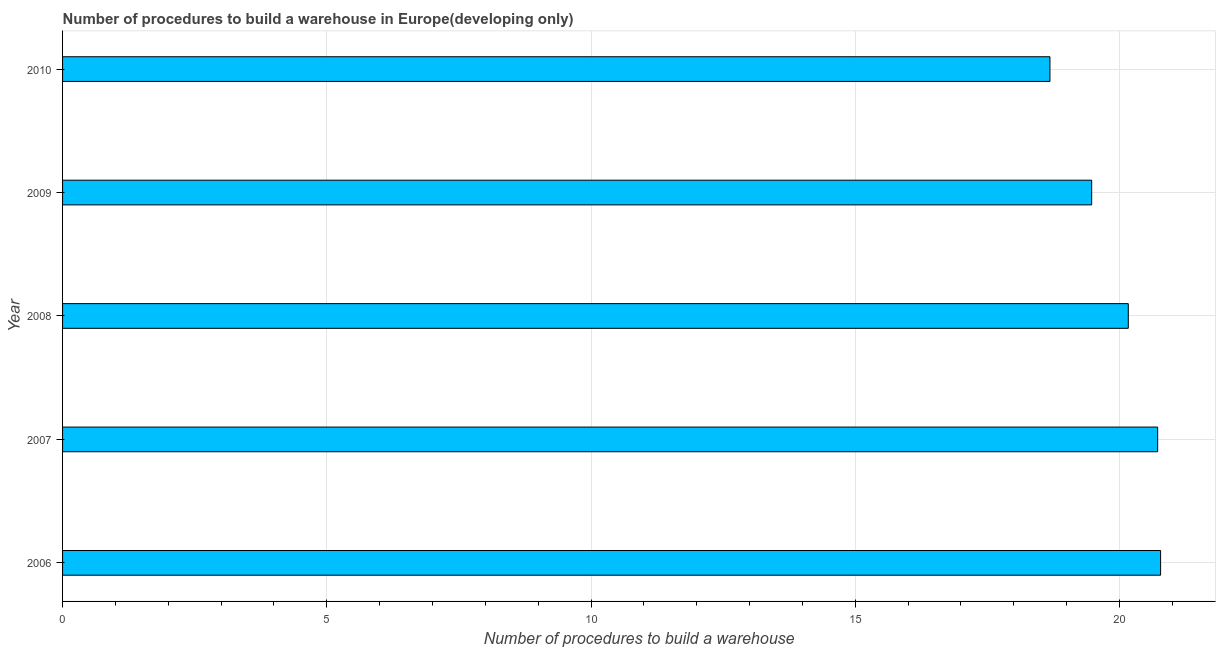What is the title of the graph?
Your answer should be compact. Number of procedures to build a warehouse in Europe(developing only). What is the label or title of the X-axis?
Make the answer very short. Number of procedures to build a warehouse. What is the number of procedures to build a warehouse in 2009?
Provide a succinct answer. 19.47. Across all years, what is the maximum number of procedures to build a warehouse?
Keep it short and to the point. 20.78. Across all years, what is the minimum number of procedures to build a warehouse?
Give a very brief answer. 18.68. In which year was the number of procedures to build a warehouse minimum?
Provide a succinct answer. 2010. What is the sum of the number of procedures to build a warehouse?
Your response must be concise. 99.82. What is the difference between the number of procedures to build a warehouse in 2006 and 2007?
Give a very brief answer. 0.06. What is the average number of procedures to build a warehouse per year?
Keep it short and to the point. 19.96. What is the median number of procedures to build a warehouse?
Make the answer very short. 20.17. In how many years, is the number of procedures to build a warehouse greater than 10 ?
Ensure brevity in your answer.  5. Do a majority of the years between 2006 and 2010 (inclusive) have number of procedures to build a warehouse greater than 8 ?
Your response must be concise. Yes. What is the ratio of the number of procedures to build a warehouse in 2009 to that in 2010?
Ensure brevity in your answer.  1.04. Is the number of procedures to build a warehouse in 2007 less than that in 2009?
Give a very brief answer. No. What is the difference between the highest and the second highest number of procedures to build a warehouse?
Your response must be concise. 0.06. Is the sum of the number of procedures to build a warehouse in 2007 and 2008 greater than the maximum number of procedures to build a warehouse across all years?
Make the answer very short. Yes. What is the difference between the highest and the lowest number of procedures to build a warehouse?
Make the answer very short. 2.09. In how many years, is the number of procedures to build a warehouse greater than the average number of procedures to build a warehouse taken over all years?
Your answer should be very brief. 3. How many bars are there?
Your answer should be very brief. 5. Are all the bars in the graph horizontal?
Provide a short and direct response. Yes. What is the difference between two consecutive major ticks on the X-axis?
Keep it short and to the point. 5. Are the values on the major ticks of X-axis written in scientific E-notation?
Offer a very short reply. No. What is the Number of procedures to build a warehouse in 2006?
Make the answer very short. 20.78. What is the Number of procedures to build a warehouse in 2007?
Keep it short and to the point. 20.72. What is the Number of procedures to build a warehouse of 2008?
Make the answer very short. 20.17. What is the Number of procedures to build a warehouse in 2009?
Provide a short and direct response. 19.47. What is the Number of procedures to build a warehouse of 2010?
Ensure brevity in your answer.  18.68. What is the difference between the Number of procedures to build a warehouse in 2006 and 2007?
Ensure brevity in your answer.  0.06. What is the difference between the Number of procedures to build a warehouse in 2006 and 2008?
Your response must be concise. 0.61. What is the difference between the Number of procedures to build a warehouse in 2006 and 2009?
Offer a terse response. 1.3. What is the difference between the Number of procedures to build a warehouse in 2006 and 2010?
Provide a short and direct response. 2.09. What is the difference between the Number of procedures to build a warehouse in 2007 and 2008?
Your answer should be compact. 0.56. What is the difference between the Number of procedures to build a warehouse in 2007 and 2009?
Ensure brevity in your answer.  1.25. What is the difference between the Number of procedures to build a warehouse in 2007 and 2010?
Your answer should be compact. 2.04. What is the difference between the Number of procedures to build a warehouse in 2008 and 2009?
Your answer should be compact. 0.69. What is the difference between the Number of procedures to build a warehouse in 2008 and 2010?
Keep it short and to the point. 1.48. What is the difference between the Number of procedures to build a warehouse in 2009 and 2010?
Make the answer very short. 0.79. What is the ratio of the Number of procedures to build a warehouse in 2006 to that in 2007?
Offer a terse response. 1. What is the ratio of the Number of procedures to build a warehouse in 2006 to that in 2008?
Give a very brief answer. 1.03. What is the ratio of the Number of procedures to build a warehouse in 2006 to that in 2009?
Give a very brief answer. 1.07. What is the ratio of the Number of procedures to build a warehouse in 2006 to that in 2010?
Ensure brevity in your answer.  1.11. What is the ratio of the Number of procedures to build a warehouse in 2007 to that in 2008?
Provide a succinct answer. 1.03. What is the ratio of the Number of procedures to build a warehouse in 2007 to that in 2009?
Your answer should be compact. 1.06. What is the ratio of the Number of procedures to build a warehouse in 2007 to that in 2010?
Ensure brevity in your answer.  1.11. What is the ratio of the Number of procedures to build a warehouse in 2008 to that in 2009?
Your answer should be very brief. 1.04. What is the ratio of the Number of procedures to build a warehouse in 2008 to that in 2010?
Make the answer very short. 1.08. What is the ratio of the Number of procedures to build a warehouse in 2009 to that in 2010?
Your answer should be compact. 1.04. 